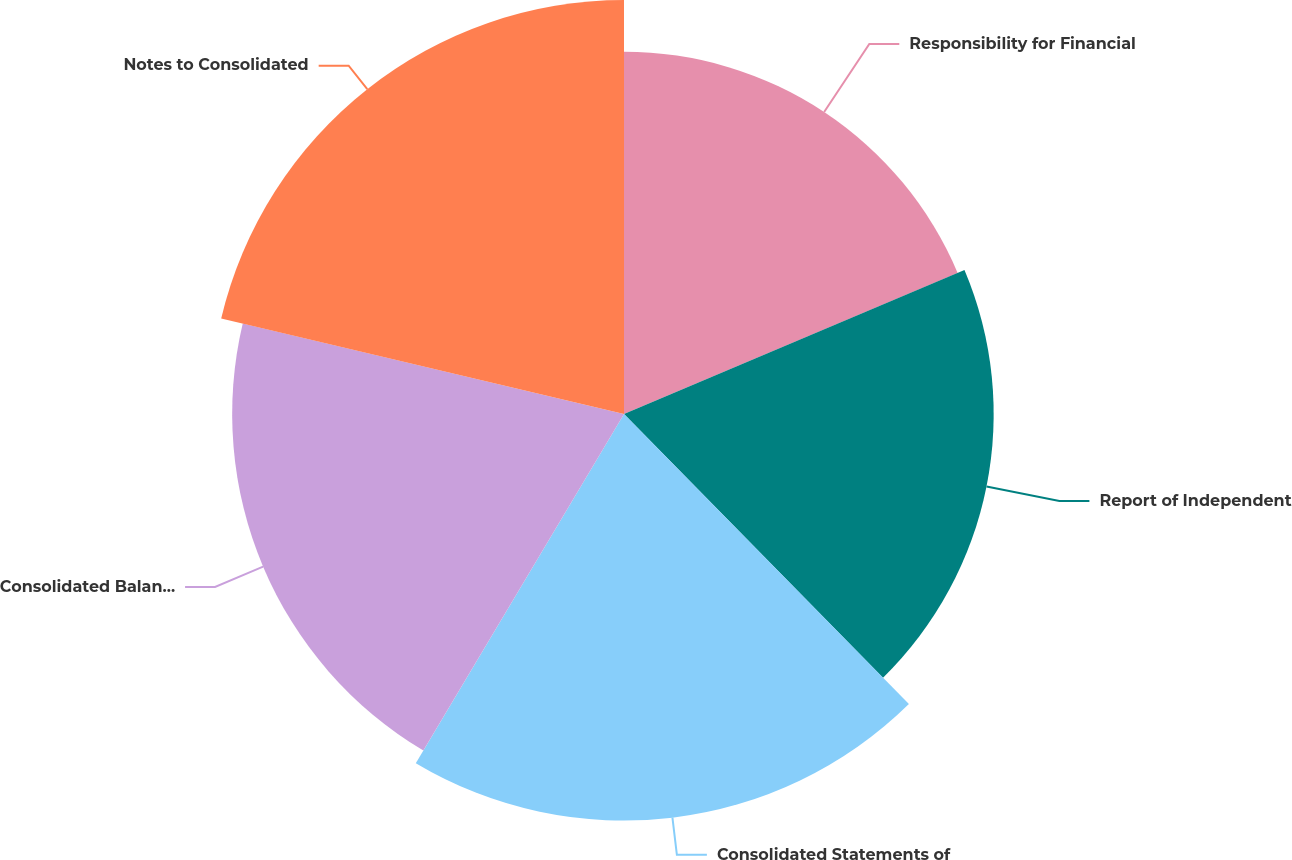Convert chart. <chart><loc_0><loc_0><loc_500><loc_500><pie_chart><fcel>Responsibility for Financial<fcel>Report of Independent<fcel>Consolidated Statements of<fcel>Consolidated Balance Sheets as<fcel>Notes to Consolidated<nl><fcel>18.63%<fcel>19.01%<fcel>20.91%<fcel>20.15%<fcel>21.29%<nl></chart> 